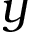Convert formula to latex. <formula><loc_0><loc_0><loc_500><loc_500>y</formula> 